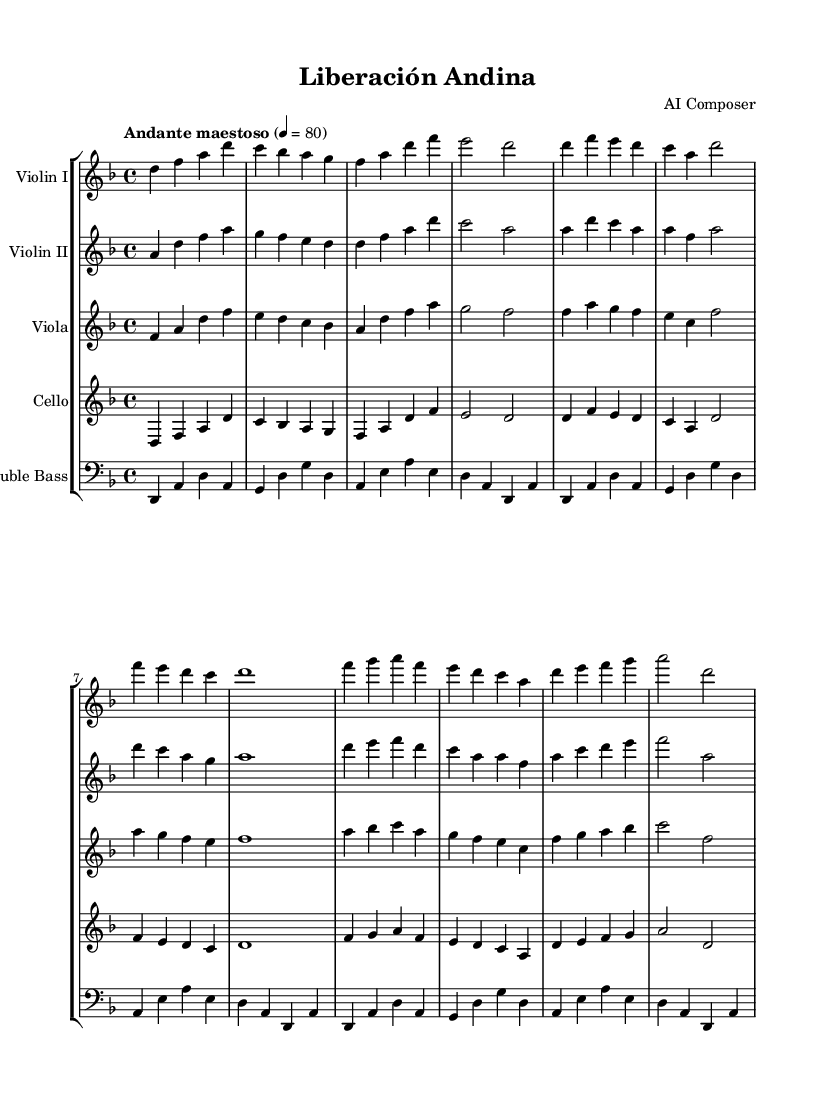What is the key signature of this music? The key signature indicated in the sheet music shows one flat, which corresponds to D minor.
Answer: D minor What is the time signature of this piece? The music notation indicates a 4/4 time signature, meaning there are four beats per measure.
Answer: 4/4 What is the tempo marking of the score? The tempo marking states "Andante maestoso," suggesting a moderately slow and majestic feel to the music.
Answer: Andante maestoso How many measures does the excerpt contain? By counting the measures in the provided score, there are a total of 16 measures present in this musical excerpt.
Answer: 16 Which instruments are included in this score? The score presents parts for Violin I, Violin II, Viola, Cello, and Double Bass, indicating a full orchestra setup.
Answer: Violin I, Violin II, Viola, Cello, Double Bass What is the highest pitch in the first violin part? Inspecting the pitches in the first violin part, the highest pitch reached is "a" in the measure sequence indicated.
Answer: a How does the harmony in the cello part relate to the overall texture? The cello part provides a foundational bass line further supporting the harmony while enhancing the orchestral texture with its lower register.
Answer: Foundational bass line 